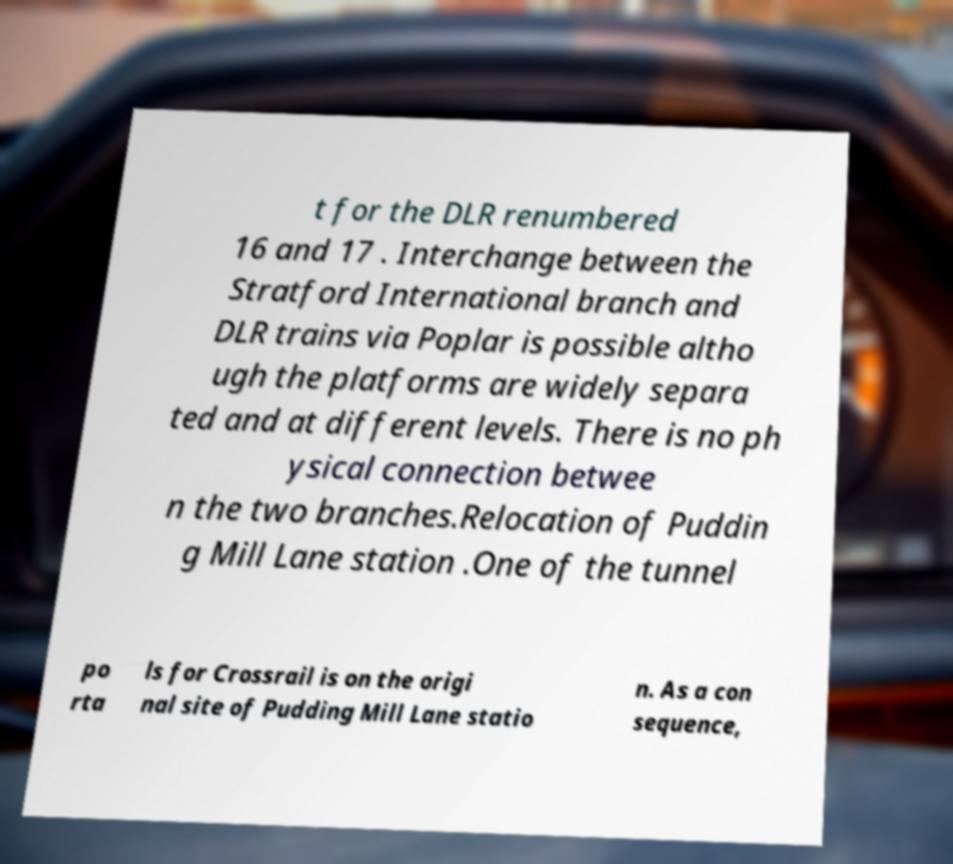What messages or text are displayed in this image? I need them in a readable, typed format. t for the DLR renumbered 16 and 17 . Interchange between the Stratford International branch and DLR trains via Poplar is possible altho ugh the platforms are widely separa ted and at different levels. There is no ph ysical connection betwee n the two branches.Relocation of Puddin g Mill Lane station .One of the tunnel po rta ls for Crossrail is on the origi nal site of Pudding Mill Lane statio n. As a con sequence, 